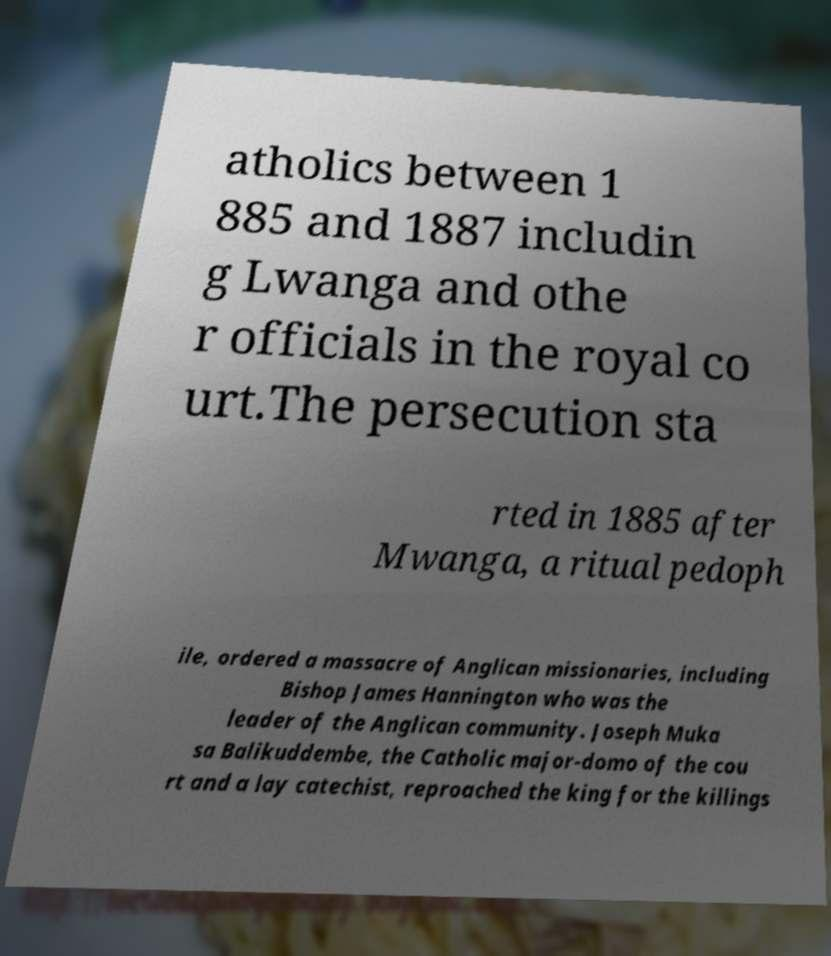Please read and relay the text visible in this image. What does it say? atholics between 1 885 and 1887 includin g Lwanga and othe r officials in the royal co urt.The persecution sta rted in 1885 after Mwanga, a ritual pedoph ile, ordered a massacre of Anglican missionaries, including Bishop James Hannington who was the leader of the Anglican community. Joseph Muka sa Balikuddembe, the Catholic major-domo of the cou rt and a lay catechist, reproached the king for the killings 